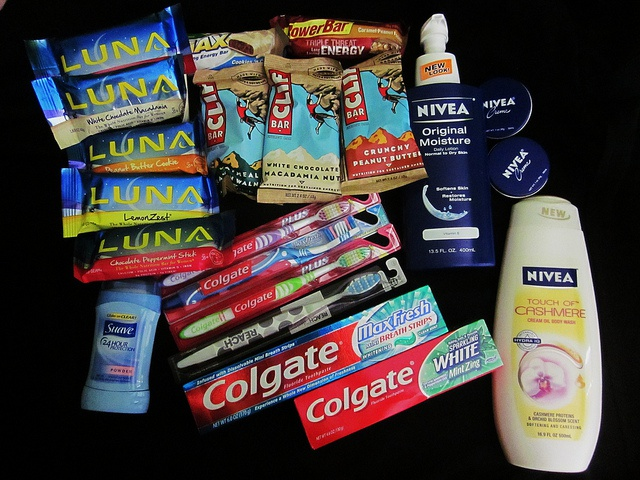Describe the objects in this image and their specific colors. I can see bottle in brown, lightgray, darkgray, beige, and tan tones, bottle in brown, black, navy, lightgray, and darkgray tones, toothbrush in brown, maroon, darkgray, and gray tones, toothbrush in brown, darkgray, black, and gray tones, and toothbrush in brown, darkgray, olive, and lightgreen tones in this image. 